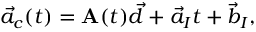<formula> <loc_0><loc_0><loc_500><loc_500>\vec { a } _ { c } ( t ) = A ( t ) \vec { d } + \vec { a } _ { I } t + \vec { b } _ { I } ,</formula> 